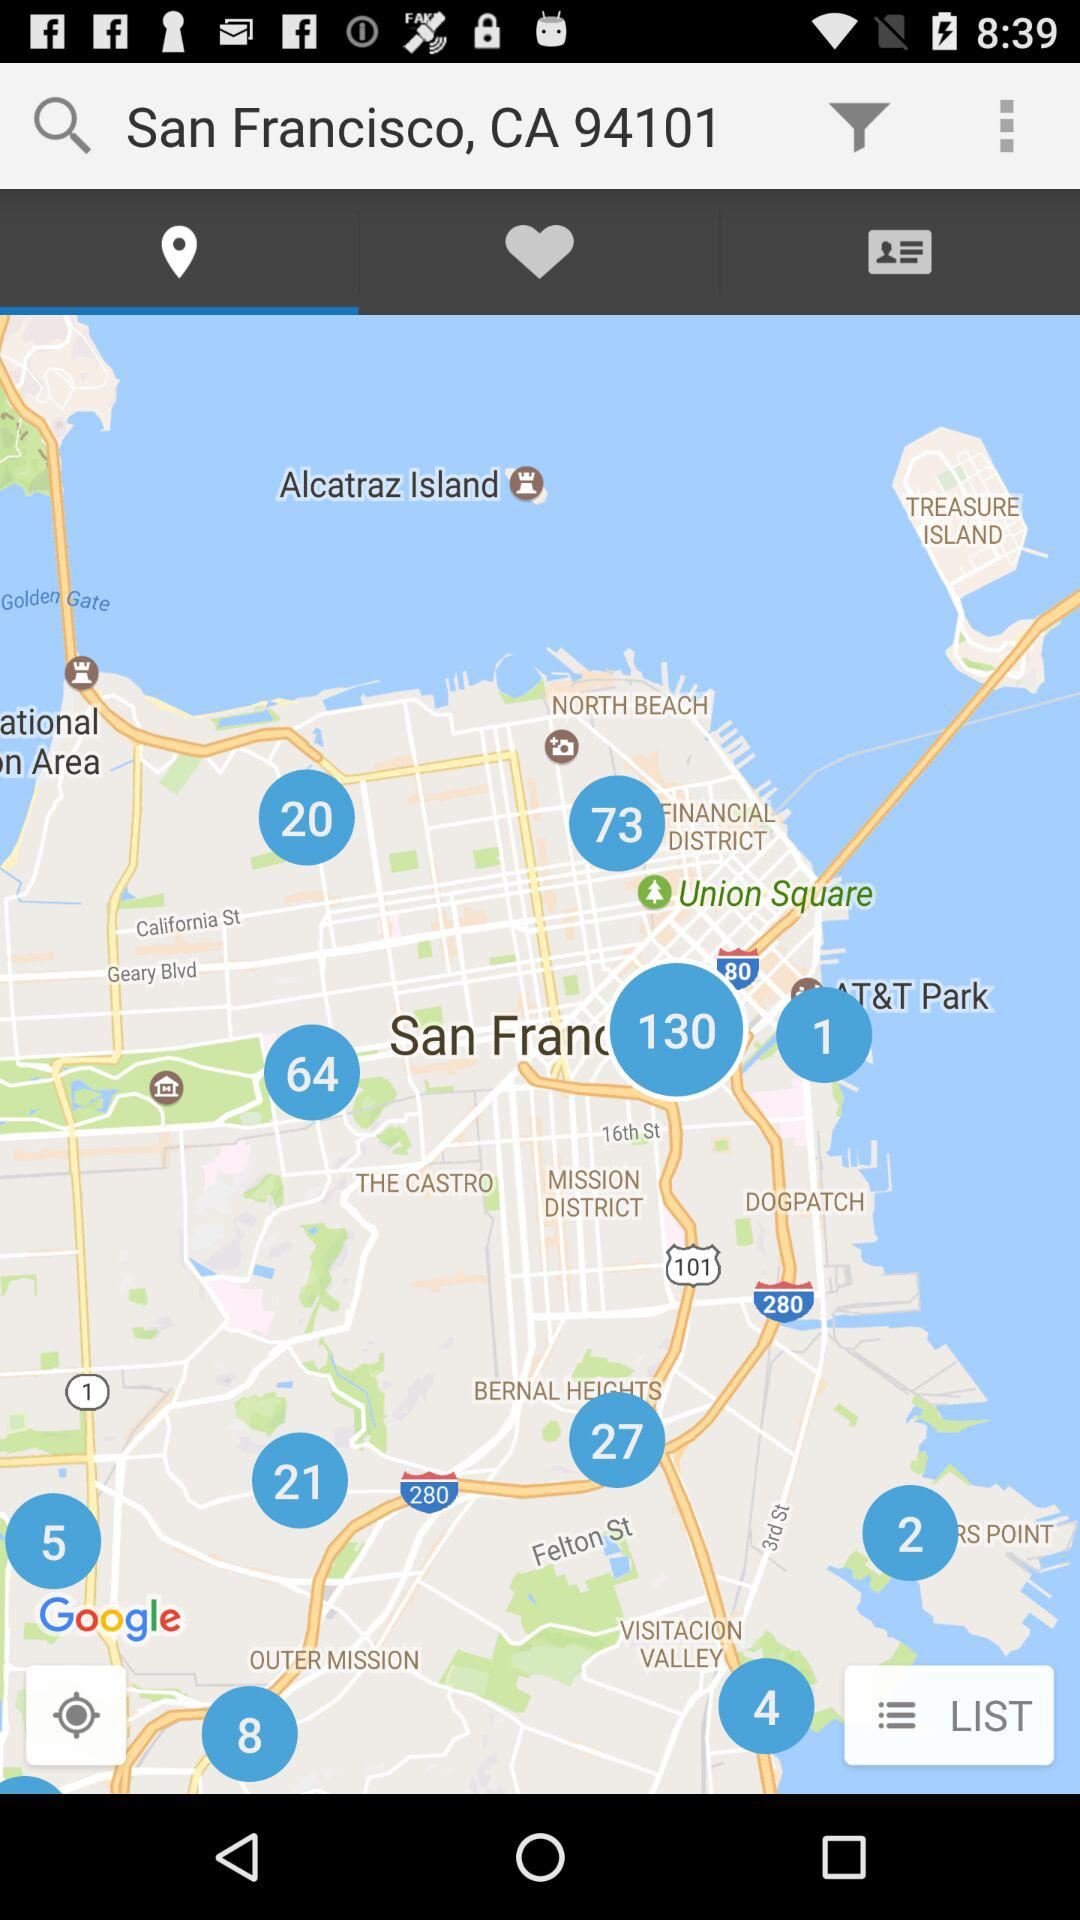What is the current location? The current location is San Francisco, CA 94101. 